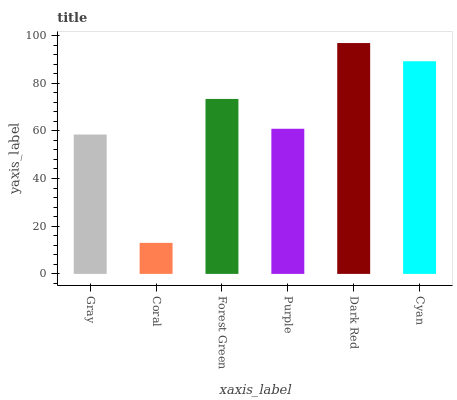Is Coral the minimum?
Answer yes or no. Yes. Is Dark Red the maximum?
Answer yes or no. Yes. Is Forest Green the minimum?
Answer yes or no. No. Is Forest Green the maximum?
Answer yes or no. No. Is Forest Green greater than Coral?
Answer yes or no. Yes. Is Coral less than Forest Green?
Answer yes or no. Yes. Is Coral greater than Forest Green?
Answer yes or no. No. Is Forest Green less than Coral?
Answer yes or no. No. Is Forest Green the high median?
Answer yes or no. Yes. Is Purple the low median?
Answer yes or no. Yes. Is Dark Red the high median?
Answer yes or no. No. Is Cyan the low median?
Answer yes or no. No. 